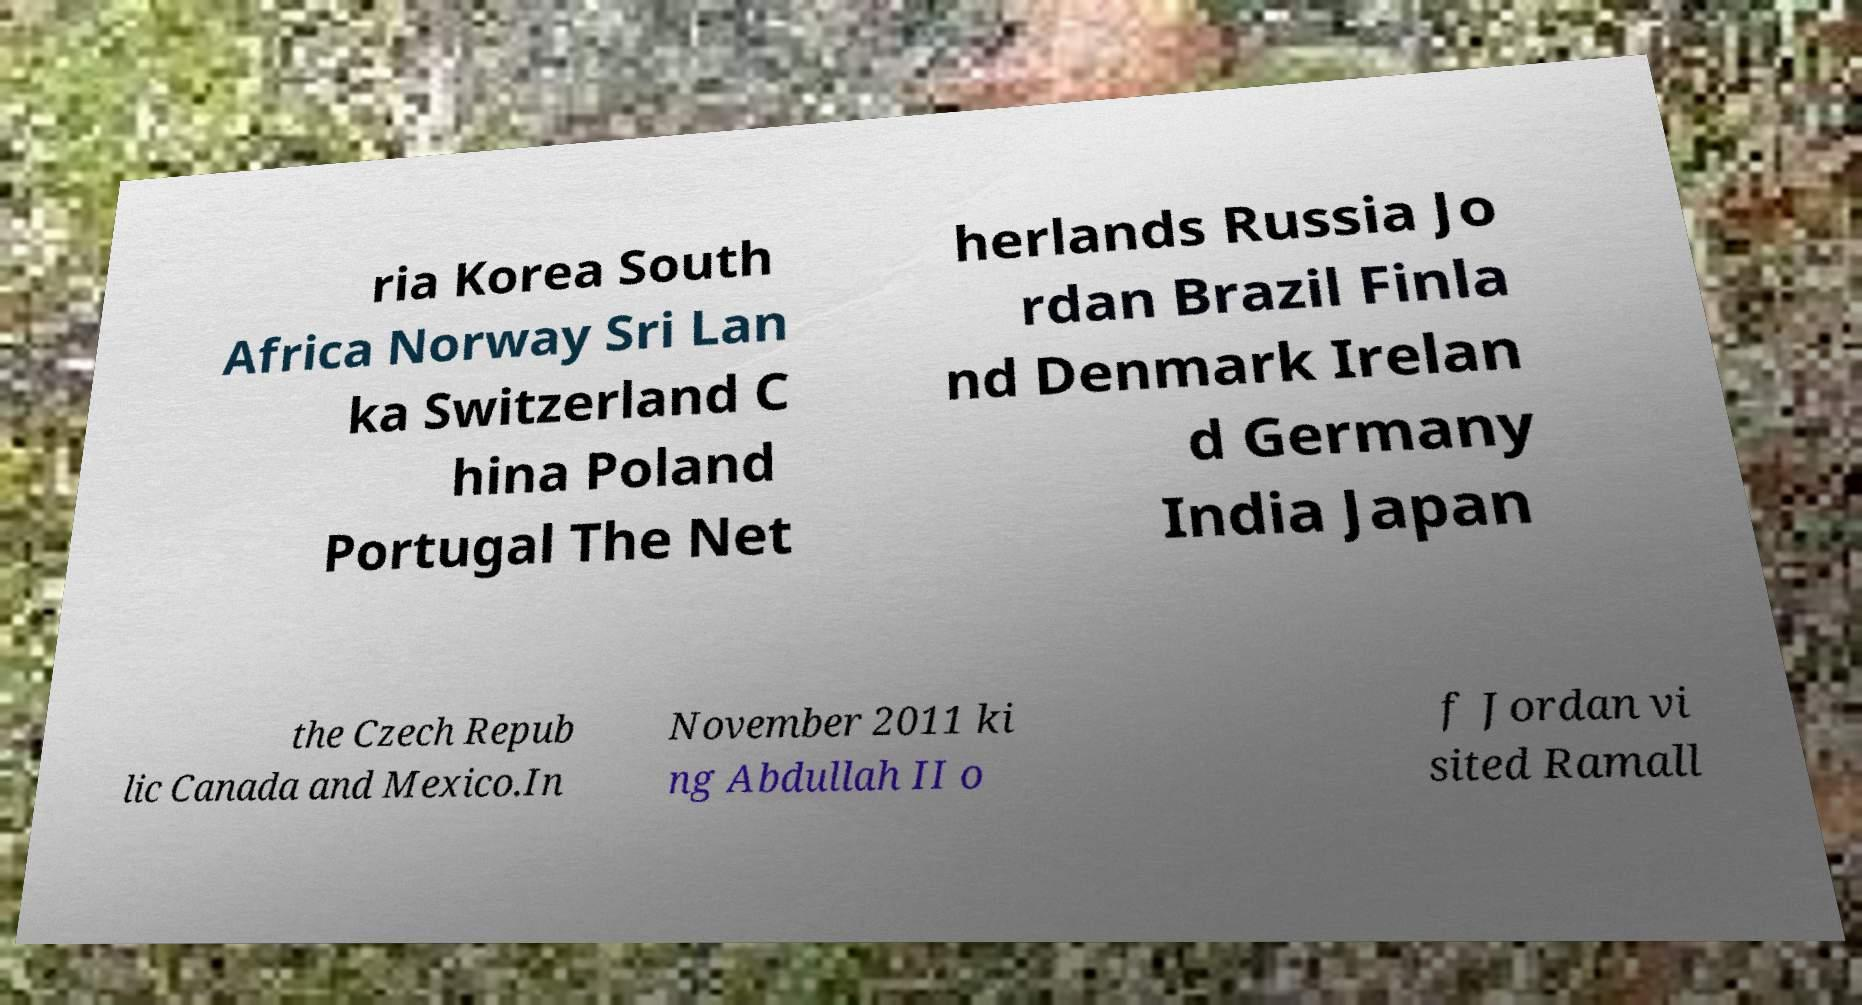Can you read and provide the text displayed in the image?This photo seems to have some interesting text. Can you extract and type it out for me? ria Korea South Africa Norway Sri Lan ka Switzerland C hina Poland Portugal The Net herlands Russia Jo rdan Brazil Finla nd Denmark Irelan d Germany India Japan the Czech Repub lic Canada and Mexico.In November 2011 ki ng Abdullah II o f Jordan vi sited Ramall 